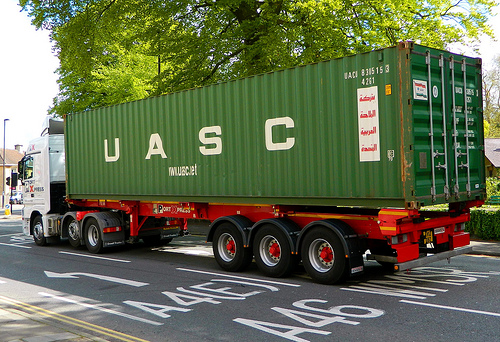How big is the container that is to the right of the cab? The container located to the right of the cab is quite large in size. 